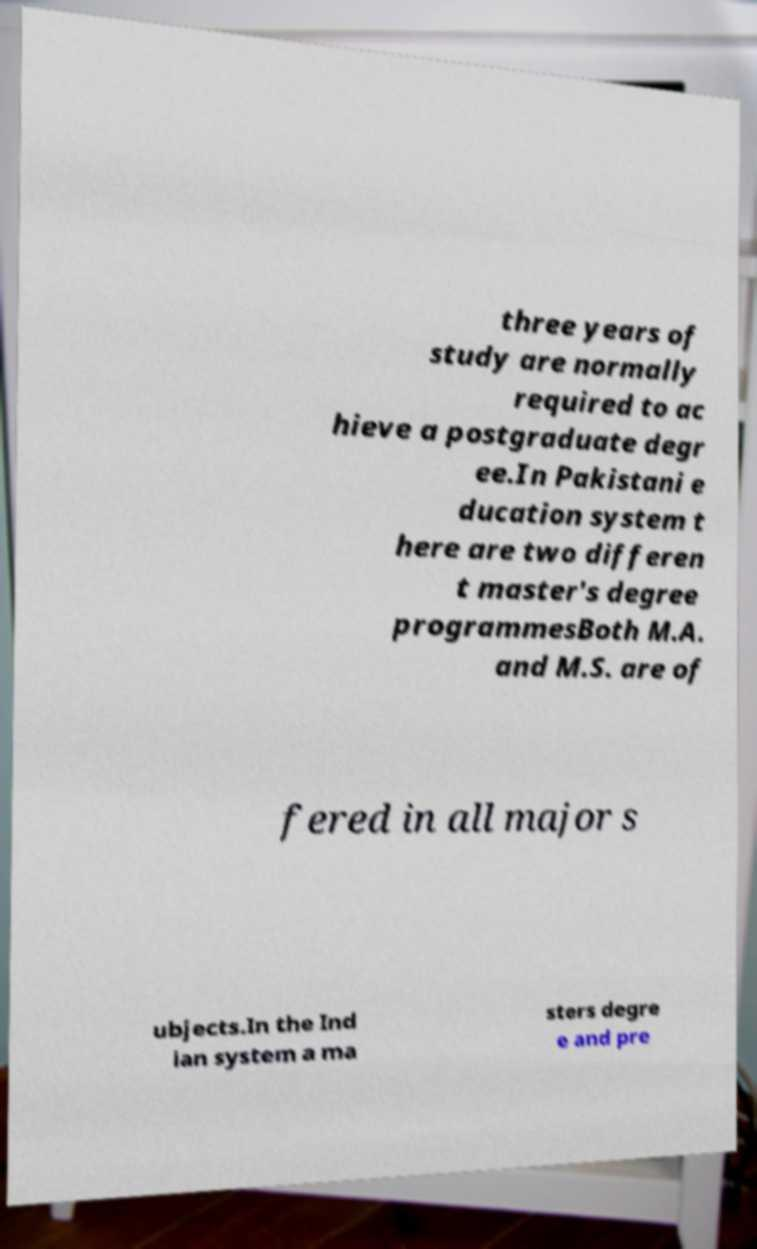Could you assist in decoding the text presented in this image and type it out clearly? three years of study are normally required to ac hieve a postgraduate degr ee.In Pakistani e ducation system t here are two differen t master's degree programmesBoth M.A. and M.S. are of fered in all major s ubjects.In the Ind ian system a ma sters degre e and pre 